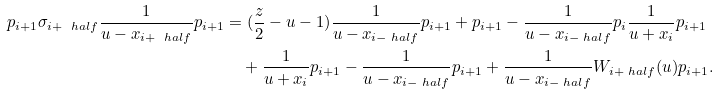Convert formula to latex. <formula><loc_0><loc_0><loc_500><loc_500>p _ { i + 1 } \sigma _ { i + \ h a l f } \frac { 1 } { u - x _ { i + \ h a l f } } p _ { i + 1 } & = ( { \frac { z } { 2 } } - u - 1 ) \frac { 1 } { u - x _ { i - \ h a l f } } p _ { i + 1 } + p _ { i + 1 } - \frac { 1 } { u - x _ { i - \ h a l f } } p _ { i } \frac { 1 } { u + x _ { i } } p _ { i + 1 } \\ & \quad + \frac { 1 } { u + x _ { i } } p _ { i + 1 } - \frac { 1 } { u - x _ { i - \ h a l f } } p _ { i + 1 } + \frac { 1 } { u - x _ { i - \ h a l f } } { W _ { i + \ h a l f } ( u ) } p _ { i + 1 } .</formula> 